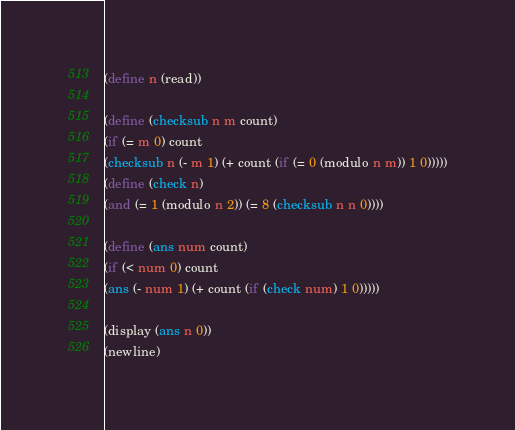Convert code to text. <code><loc_0><loc_0><loc_500><loc_500><_Scheme_>(define n (read))
 
(define (checksub n m count)
(if (= m 0) count
(checksub n (- m 1) (+ count (if (= 0 (modulo n m)) 1 0)))))
(define (check n)
(and (= 1 (modulo n 2)) (= 8 (checksub n n 0))))
 
(define (ans num count)
(if (< num 0) count
(ans (- num 1) (+ count (if (check num) 1 0)))))
 
(display (ans n 0))
(newline)</code> 